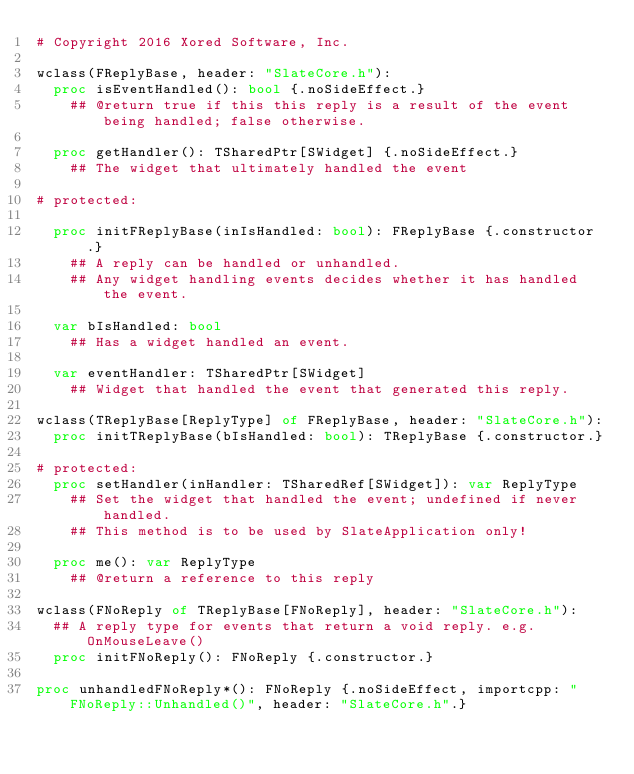Convert code to text. <code><loc_0><loc_0><loc_500><loc_500><_Nim_># Copyright 2016 Xored Software, Inc.

wclass(FReplyBase, header: "SlateCore.h"):
  proc isEventHandled(): bool {.noSideEffect.}
    ## @return true if this this reply is a result of the event being handled; false otherwise.

  proc getHandler(): TSharedPtr[SWidget] {.noSideEffect.}
    ## The widget that ultimately handled the event

# protected:

  proc initFReplyBase(inIsHandled: bool): FReplyBase {.constructor.}
    ## A reply can be handled or unhandled.
    ## Any widget handling events decides whether it has handled the event.

  var bIsHandled: bool
    ## Has a widget handled an event.

  var eventHandler: TSharedPtr[SWidget]
    ## Widget that handled the event that generated this reply.

wclass(TReplyBase[ReplyType] of FReplyBase, header: "SlateCore.h"):
  proc initTReplyBase(bIsHandled: bool): TReplyBase {.constructor.}

# protected:
  proc setHandler(inHandler: TSharedRef[SWidget]): var ReplyType
    ## Set the widget that handled the event; undefined if never handled.
    ## This method is to be used by SlateApplication only!

  proc me(): var ReplyType
    ## @return a reference to this reply

wclass(FNoReply of TReplyBase[FNoReply], header: "SlateCore.h"):
  ## A reply type for events that return a void reply. e.g. OnMouseLeave()
  proc initFNoReply(): FNoReply {.constructor.}

proc unhandledFNoReply*(): FNoReply {.noSideEffect, importcpp: "FNoReply::Unhandled()", header: "SlateCore.h".}
</code> 